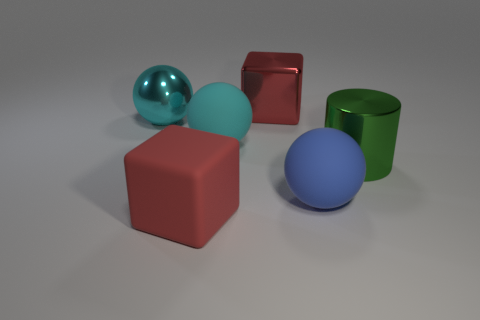Add 1 metal cubes. How many objects exist? 7 Subtract all large cyan balls. How many balls are left? 1 Subtract all blue balls. How many balls are left? 2 Subtract 1 cubes. How many cubes are left? 1 Subtract all blue spheres. Subtract all purple cubes. How many spheres are left? 2 Subtract all blue balls. How many cyan cylinders are left? 0 Subtract all big rubber balls. Subtract all purple rubber balls. How many objects are left? 4 Add 5 large matte objects. How many large matte objects are left? 8 Add 2 big metallic things. How many big metallic things exist? 5 Subtract 0 brown cylinders. How many objects are left? 6 